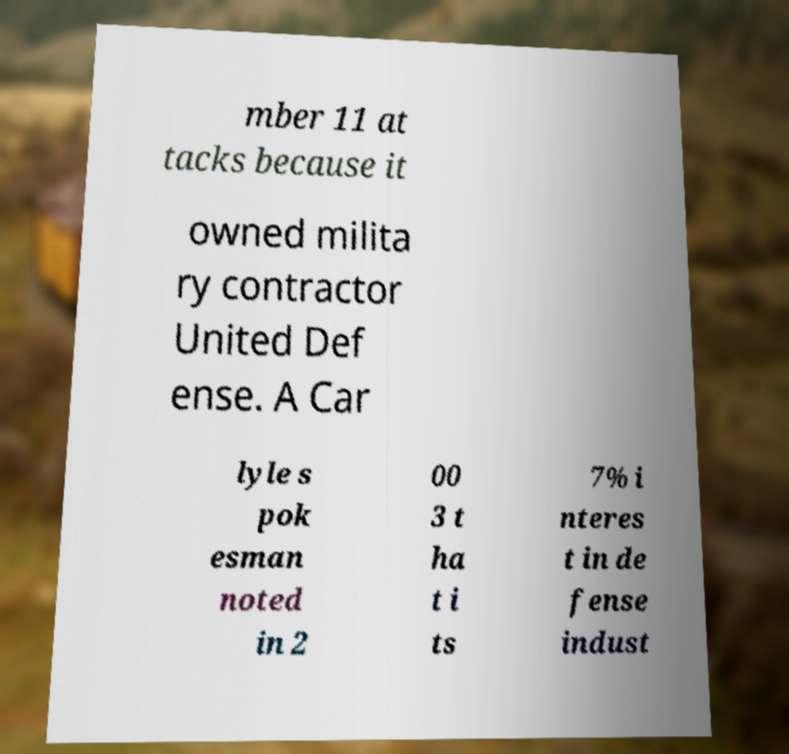Could you extract and type out the text from this image? mber 11 at tacks because it owned milita ry contractor United Def ense. A Car lyle s pok esman noted in 2 00 3 t ha t i ts 7% i nteres t in de fense indust 